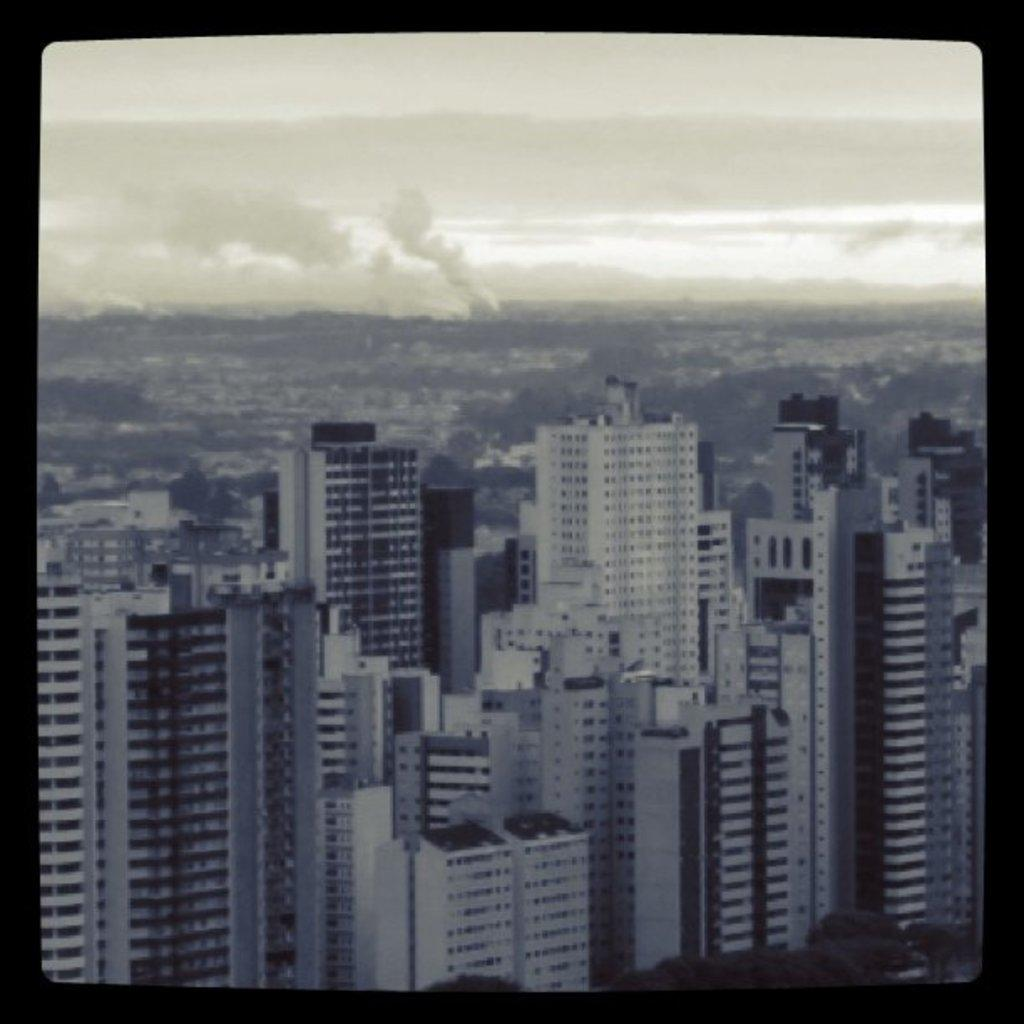What type of structures are present in the image? There are tall buildings in the image. What can be seen at the top of the image? The sky is visible at the top of the image. What type of street is shown in the image? There is no street visible in the image; it only shows tall buildings and the sky. Can you tell me how many fans are present in the image? There are no fans present in the image. 